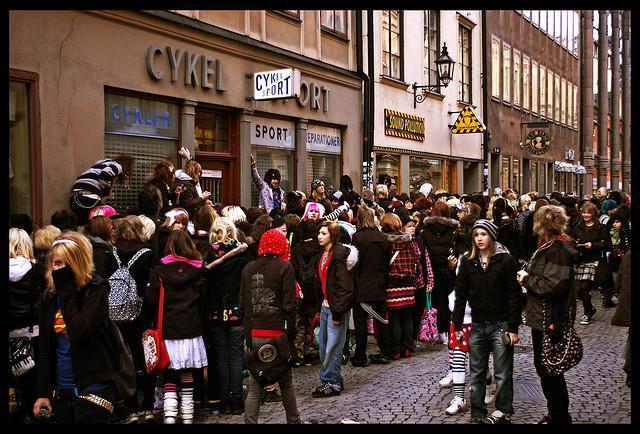How many people are in the photo?
Give a very brief answer. 11. 